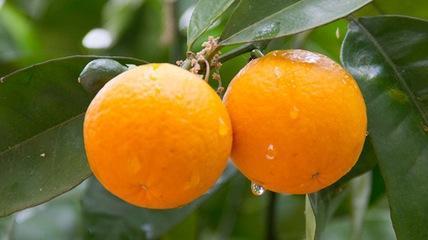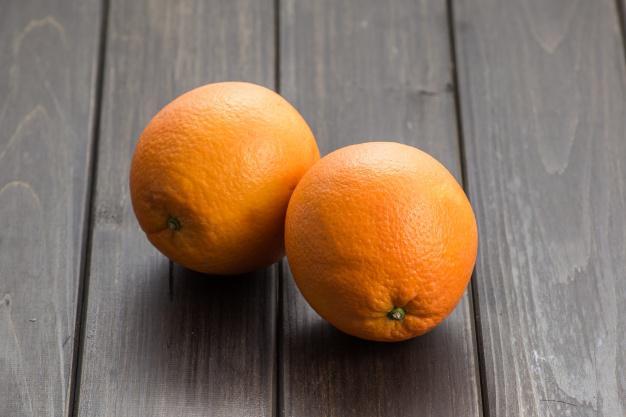The first image is the image on the left, the second image is the image on the right. Evaluate the accuracy of this statement regarding the images: "There are four unpeeled oranges in the pair of images.". Is it true? Answer yes or no. Yes. The first image is the image on the left, the second image is the image on the right. For the images shown, is this caption "One of the images has two whole oranges with no partially cut oranges." true? Answer yes or no. Yes. 